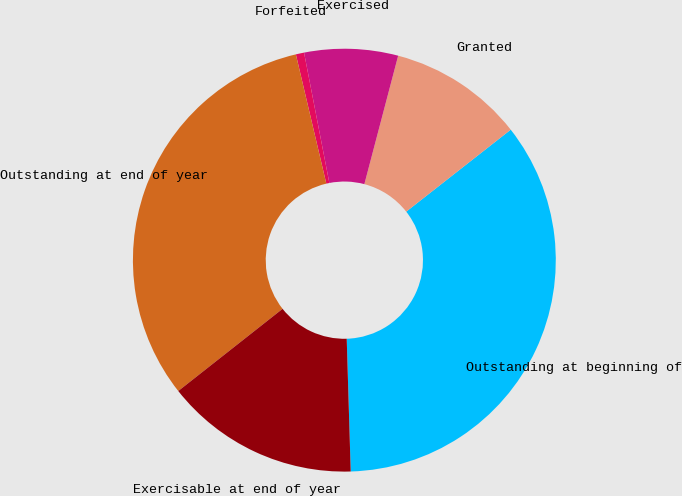Convert chart. <chart><loc_0><loc_0><loc_500><loc_500><pie_chart><fcel>Outstanding at beginning of<fcel>Granted<fcel>Exercised<fcel>Forfeited<fcel>Outstanding at end of year<fcel>Exercisable at end of year<nl><fcel>35.11%<fcel>10.32%<fcel>7.15%<fcel>0.63%<fcel>31.94%<fcel>14.86%<nl></chart> 